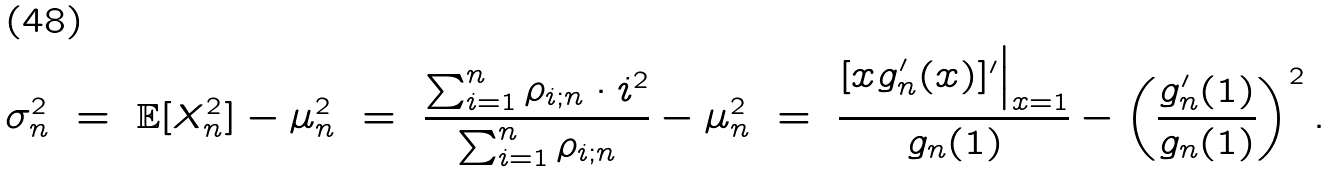<formula> <loc_0><loc_0><loc_500><loc_500>\sigma _ { n } ^ { 2 } \ = \ \mathbb { E } [ X _ { n } ^ { 2 } ] - \mu _ { n } ^ { 2 } \ = \ \frac { \sum _ { i = 1 } ^ { n } \rho _ { i ; n } \cdot i ^ { 2 } } { \sum _ { i = 1 } ^ { n } \rho _ { i ; n } } - \mu _ { n } ^ { 2 } \ = \ \frac { [ x g ^ { \prime } _ { n } ( x ) ] ^ { \prime } \Big | _ { x = 1 } } { g _ { n } ( 1 ) } - \left ( \frac { g _ { n } ^ { \prime } ( 1 ) } { g _ { n } ( 1 ) } \right ) ^ { 2 } .</formula> 